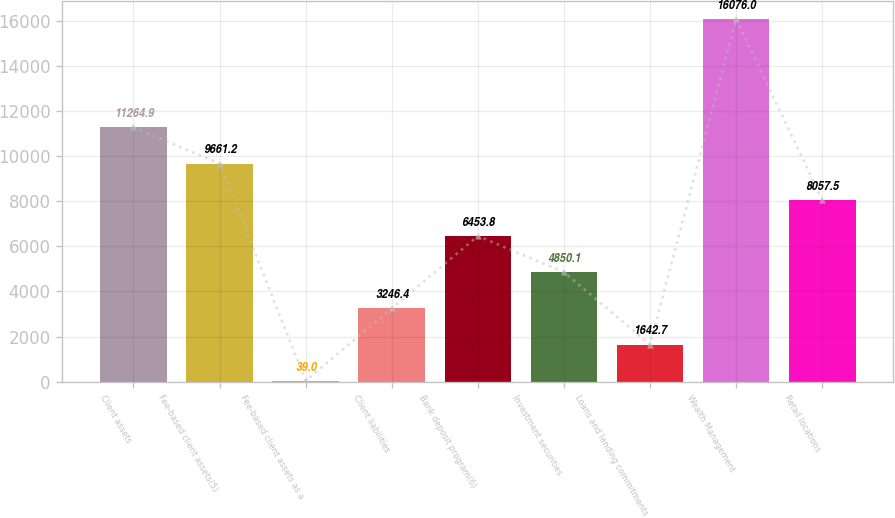<chart> <loc_0><loc_0><loc_500><loc_500><bar_chart><fcel>Client assets<fcel>Fee-based client assets(5)<fcel>Fee-based client assets as a<fcel>Client liabilities<fcel>Bank deposit program(6)<fcel>Investment securities<fcel>Loans and lending commitments<fcel>Wealth Management<fcel>Retail locations<nl><fcel>11264.9<fcel>9661.2<fcel>39<fcel>3246.4<fcel>6453.8<fcel>4850.1<fcel>1642.7<fcel>16076<fcel>8057.5<nl></chart> 